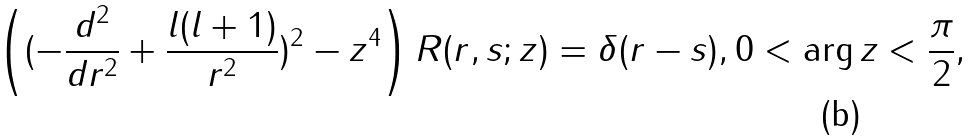Convert formula to latex. <formula><loc_0><loc_0><loc_500><loc_500>\left ( ( - \frac { d ^ { 2 } } { d r ^ { 2 } } + \frac { l ( l + 1 ) } { r ^ { 2 } } ) ^ { 2 } - z ^ { 4 } \right ) R ( r , s ; z ) = \delta ( r - s ) , 0 < \arg z < \frac { \pi } { 2 } ,</formula> 